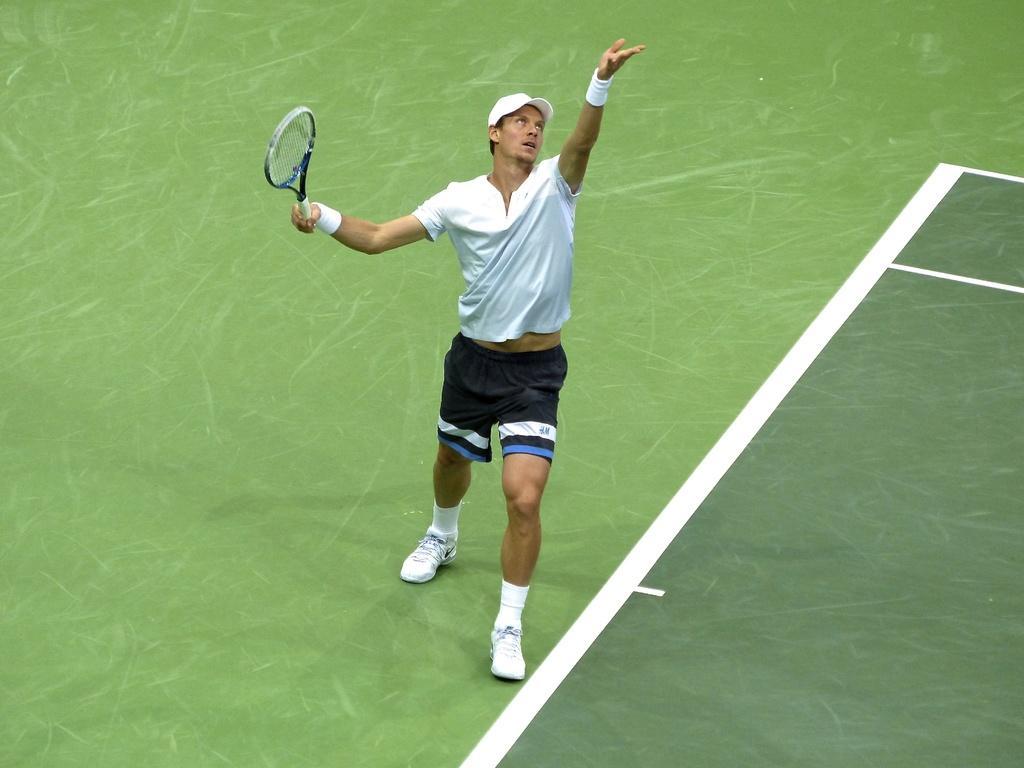In one or two sentences, can you explain what this image depicts? In this image, I can see the man standing and holding a tennis racket. The background looks green and white in color. 